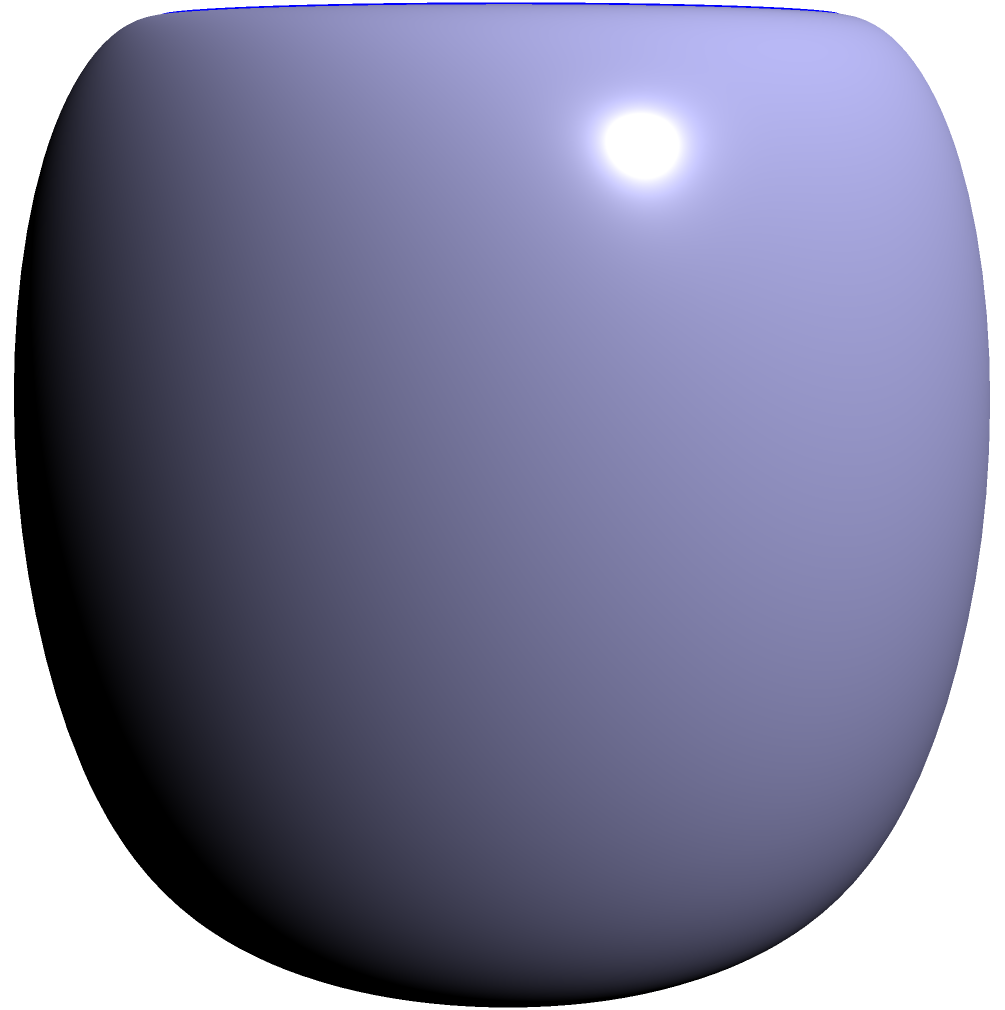Two cylindrical lens shapes are represented by the equations:

$$x^2 + y^2 = 4$$ (Lens 1)
$$(x-1)^2 + (y-1)^2 = 1$$ (Lens 2)

Both cylinders have a height of 2 units along the z-axis, centered at z = 0. What is the volume of the intersection of these two lens shapes? To solve this problem, we'll follow these steps:

1) First, we need to find the area of intersection of the two circles in the xy-plane:

   Lens 1: $x^2 + y^2 = 4$
   Lens 2: $(x-1)^2 + (y-1)^2 = 1$

2) To find the intersection points, we can solve these equations simultaneously:
   
   Let $x = 2\cos\theta$ and $y = 2\sin\theta$ (parameterization of Lens 1)
   
   Substituting into the equation of Lens 2:
   
   $((2\cos\theta-1)^2 + (2\sin\theta-1)^2 = 1$

3) Simplifying:
   
   $4\cos^2\theta - 4\cos\theta + 1 + 4\sin^2\theta - 4\sin\theta + 1 = 1$
   
   $4(\cos^2\theta + \sin^2\theta) - 4(\cos\theta + \sin\theta) + 1 = 1$
   
   $4 - 4(\cos\theta + \sin\theta) = 0$
   
   $\cos\theta + \sin\theta = 1$

4) This can be solved to give $\theta = \frac{\pi}{4}$ and $\theta = \frac{5\pi}{4}$

5) The intersection points are thus:
   
   $(\sqrt{2}, \sqrt{2})$ and $(-\sqrt{2}, -\sqrt{2})$

6) The area of intersection can be found by subtracting the areas of two circular segments from the area of Lens 1:

   Area = $\pi r_1^2 - 2(r_1^2 \arccos(\frac{d}{2r_1}) - \frac{d}{2}\sqrt{r_1^2 - \frac{d^2}{4}})$
        $+ \pi r_2^2 - 2(r_2^2 \arccos(\frac{d}{2r_2}) - \frac{d}{2}\sqrt{r_2^2 - \frac{d^2}{4}})$

   Where $r_1 = 2$, $r_2 = 1$, and $d = \sqrt{2}$ (distance between centers)

7) Calculating this gives an area of approximately 3.1416 square units.

8) Since the height of both cylinders is 2 units, the volume of intersection is:

   Volume = 3.1416 * 2 = 6.2832 cubic units
Answer: 6.2832 cubic units 